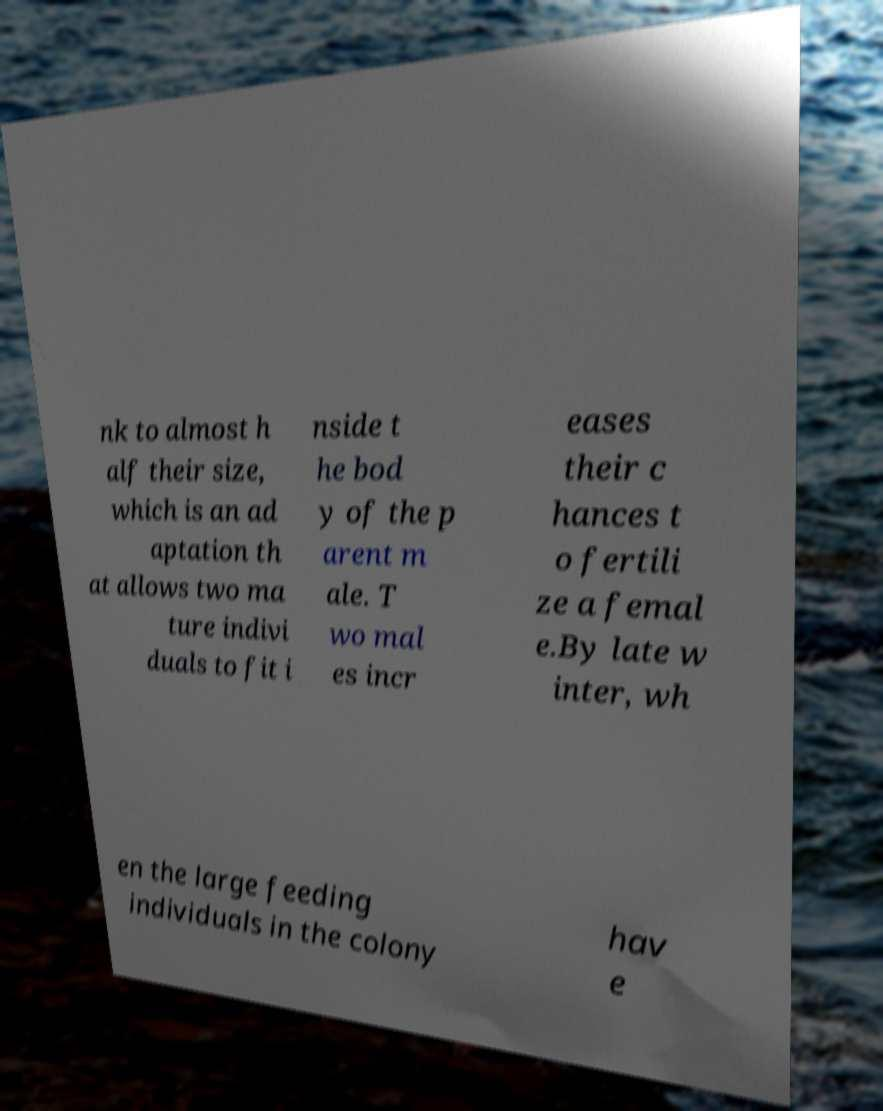Please identify and transcribe the text found in this image. nk to almost h alf their size, which is an ad aptation th at allows two ma ture indivi duals to fit i nside t he bod y of the p arent m ale. T wo mal es incr eases their c hances t o fertili ze a femal e.By late w inter, wh en the large feeding individuals in the colony hav e 